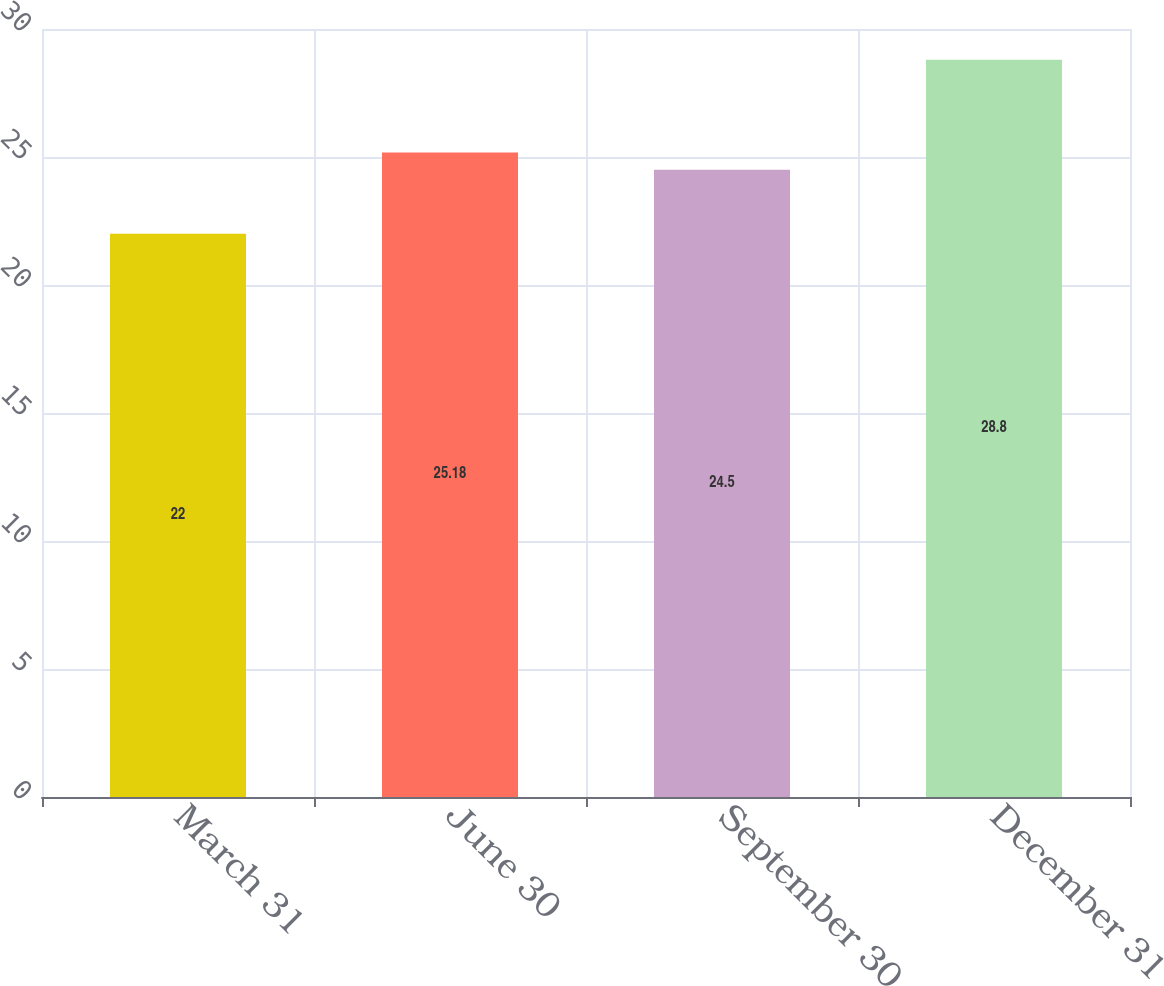Convert chart. <chart><loc_0><loc_0><loc_500><loc_500><bar_chart><fcel>March 31<fcel>June 30<fcel>September 30<fcel>December 31<nl><fcel>22<fcel>25.18<fcel>24.5<fcel>28.8<nl></chart> 